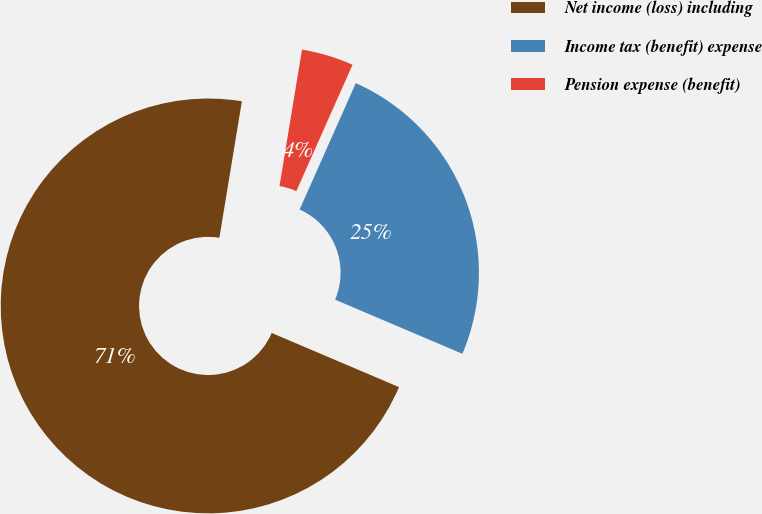<chart> <loc_0><loc_0><loc_500><loc_500><pie_chart><fcel>Net income (loss) including<fcel>Income tax (benefit) expense<fcel>Pension expense (benefit)<nl><fcel>71.2%<fcel>24.74%<fcel>4.06%<nl></chart> 